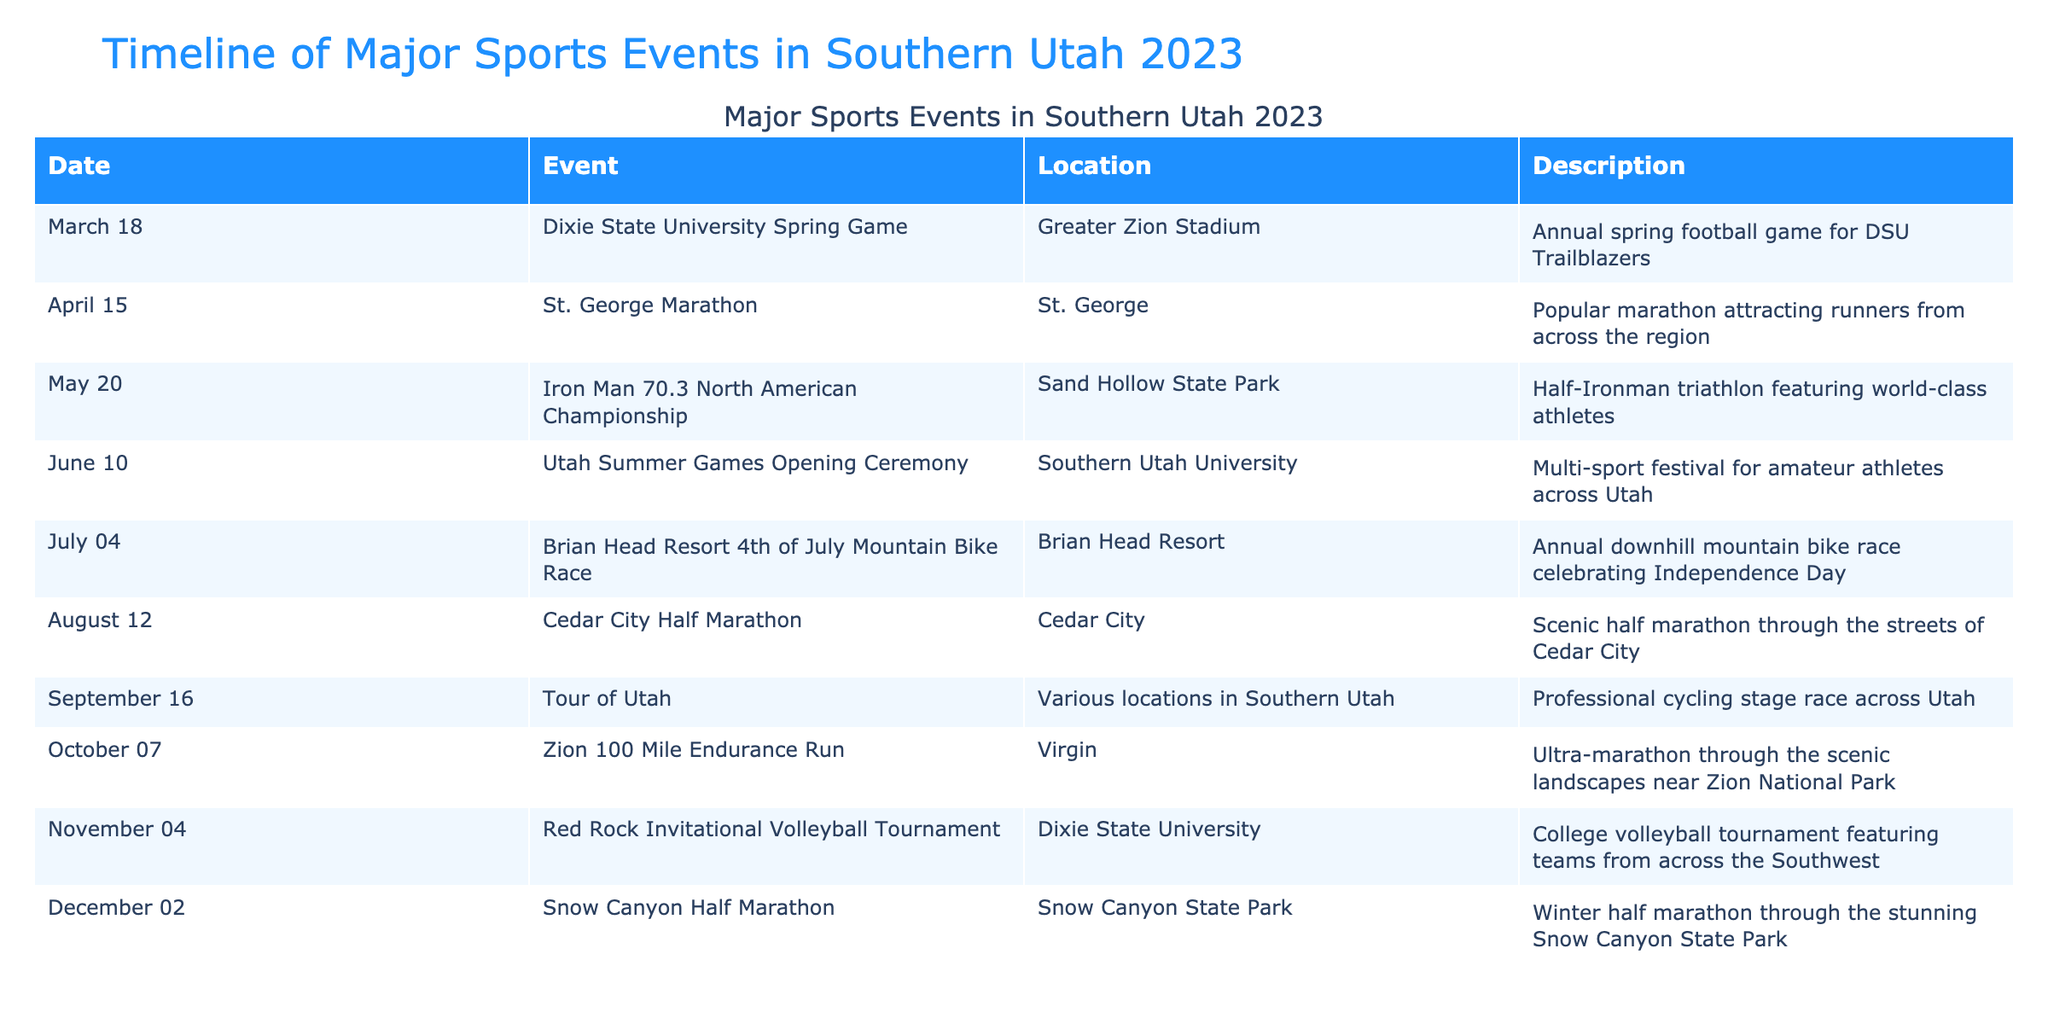What event took place on March 18, 2023? The table shows that on March 18, 2023, the Dixie State University Spring Game occurred at Greater Zion Stadium.
Answer: Dixie State University Spring Game How many events were held in Southern Utah in June 2023? According to the table, there is one event listed in June 2023, which is the Utah Summer Games Opening Ceremony on June 10.
Answer: 1 event Was the Iron Man 70.3 North American Championship a running event? The table indicates that the Iron Man 70.3 North American Championship, held on May 20, 2023, is a half-Ironman triathlon, which includes swimming, biking, and running, but running alone isn't the focus.
Answer: No Which event took place at Dixie State University in November 2023? The table lists the Red Rock Invitational Volleyball Tournament as the event held at Dixie State University on November 4, 2023.
Answer: Red Rock Invitational Volleyball Tournament What is the average number of days between events from March to October 2023? Analyzing the dates, there are a total of seven events from March 18 to October 7, 2023. The dates are March 18, April 15, May 20, June 10, July 4, August 12, September 16, and October 7. The span is 203 days across 7 intervals, resulting in an average of 29 days apart.
Answer: 29 days How many events occurred in the second half of the year (July to December)? The events in the second half of 2023 from the table are: Brian Head Resort 4th of July Mountain Bike Race, Cedar City Half Marathon, Tour of Utah, Zion 100 Mile Endurance Run, Red Rock Invitational Volleyball Tournament, and Snow Canyon Half Marathon, totaling six events.
Answer: 6 events Is the St. George Marathon held in a city named after a saint? Yes, the St. George Marathon takes place in the city of St. George.
Answer: Yes What was the last major sports event in Southern Utah in 2023? The table indicates that the last major sports event for the year was the Snow Canyon Half Marathon, which took place on December 2, 2023.
Answer: Snow Canyon Half Marathon 